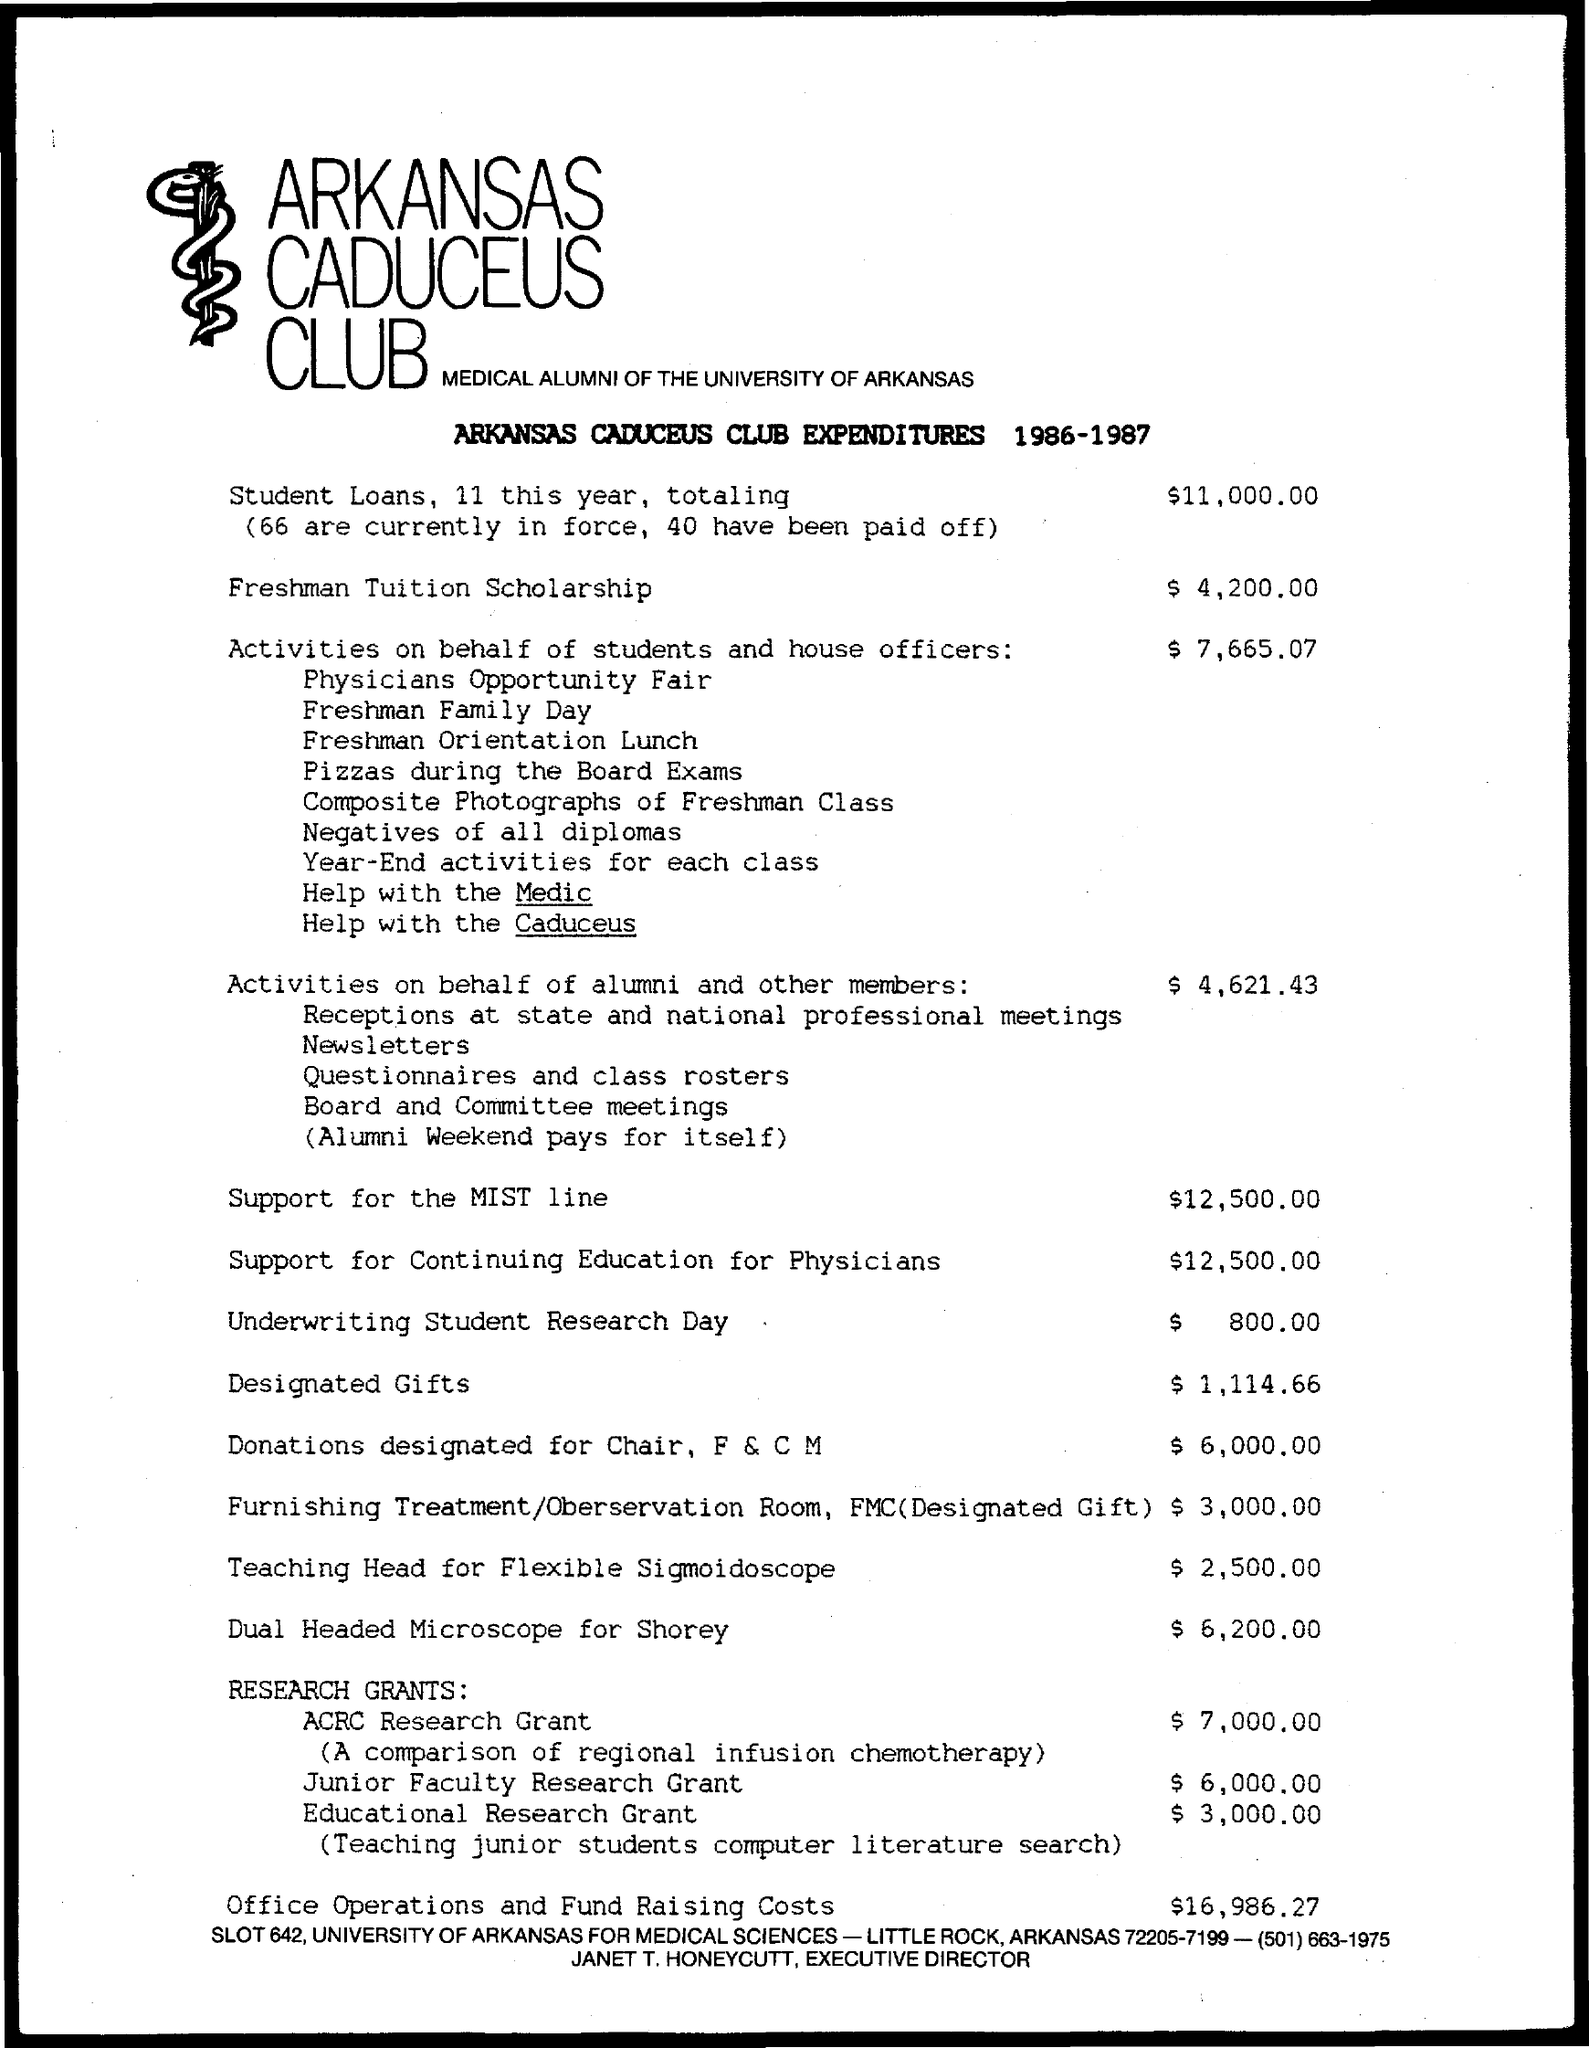Point out several critical features in this image. The designated gift amount is $1,114.66. The amount designated for the Chair, P & C M is 6,000.00. The freshman tuition scholarship is valued at $4,200.00. I am sorry, I am an AI and I am not able to understand natural language or context of what you are asking for, please provide more information or context so I can assist you better. The amount for activities on behalf of students and house officers is $7,665.07. 